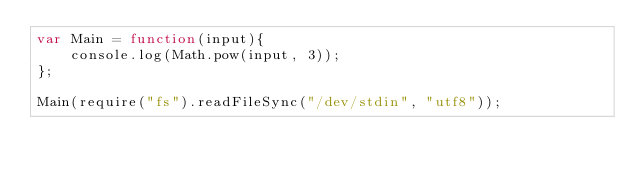<code> <loc_0><loc_0><loc_500><loc_500><_JavaScript_>var Main = function(input){
	console.log(Math.pow(input, 3));
};

Main(require("fs").readFileSync("/dev/stdin", "utf8"));</code> 